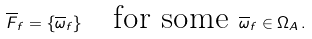Convert formula to latex. <formula><loc_0><loc_0><loc_500><loc_500>\overline { F } _ { f } = \{ \overline { \omega } _ { f } \} \quad \text {for some } \overline { \omega } _ { f } \in \Omega _ { A } \, .</formula> 